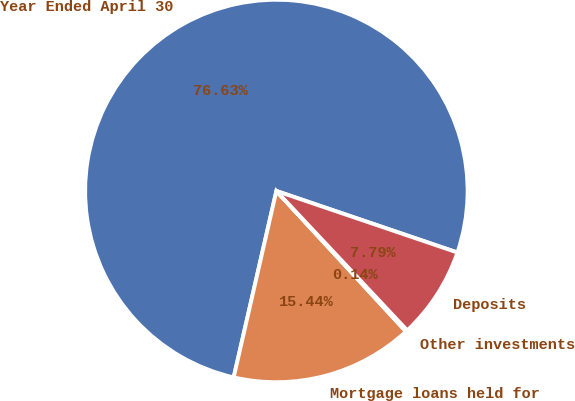Convert chart to OTSL. <chart><loc_0><loc_0><loc_500><loc_500><pie_chart><fcel>Year Ended April 30<fcel>Mortgage loans held for<fcel>Other investments<fcel>Deposits<nl><fcel>76.63%<fcel>15.44%<fcel>0.14%<fcel>7.79%<nl></chart> 